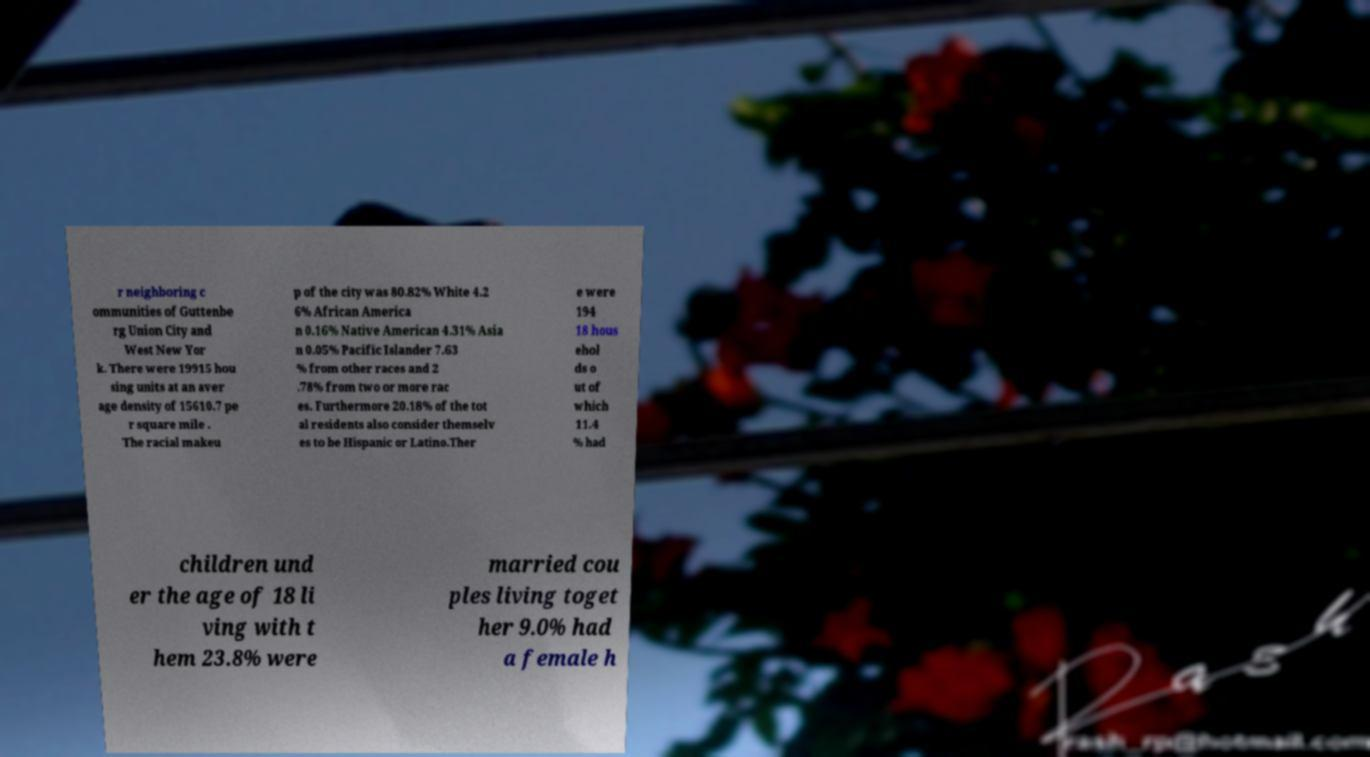For documentation purposes, I need the text within this image transcribed. Could you provide that? r neighboring c ommunities of Guttenbe rg Union City and West New Yor k. There were 19915 hou sing units at an aver age density of 15610.7 pe r square mile . The racial makeu p of the city was 80.82% White 4.2 6% African America n 0.16% Native American 4.31% Asia n 0.05% Pacific Islander 7.63 % from other races and 2 .78% from two or more rac es. Furthermore 20.18% of the tot al residents also consider themselv es to be Hispanic or Latino.Ther e were 194 18 hous ehol ds o ut of which 11.4 % had children und er the age of 18 li ving with t hem 23.8% were married cou ples living toget her 9.0% had a female h 